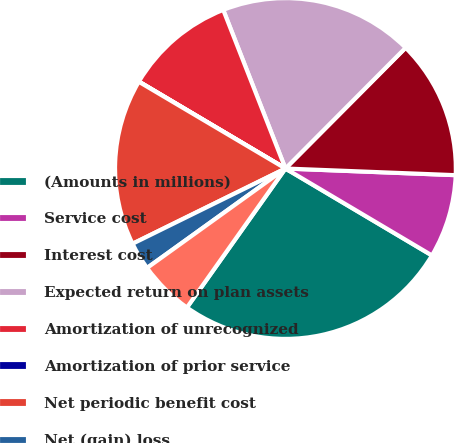Convert chart. <chart><loc_0><loc_0><loc_500><loc_500><pie_chart><fcel>(Amounts in millions)<fcel>Service cost<fcel>Interest cost<fcel>Expected return on plan assets<fcel>Amortization of unrecognized<fcel>Amortization of prior service<fcel>Net periodic benefit cost<fcel>Net (gain) loss<fcel>Total recognized in OCI<nl><fcel>26.29%<fcel>7.9%<fcel>13.16%<fcel>18.41%<fcel>10.53%<fcel>0.02%<fcel>15.78%<fcel>2.64%<fcel>5.27%<nl></chart> 